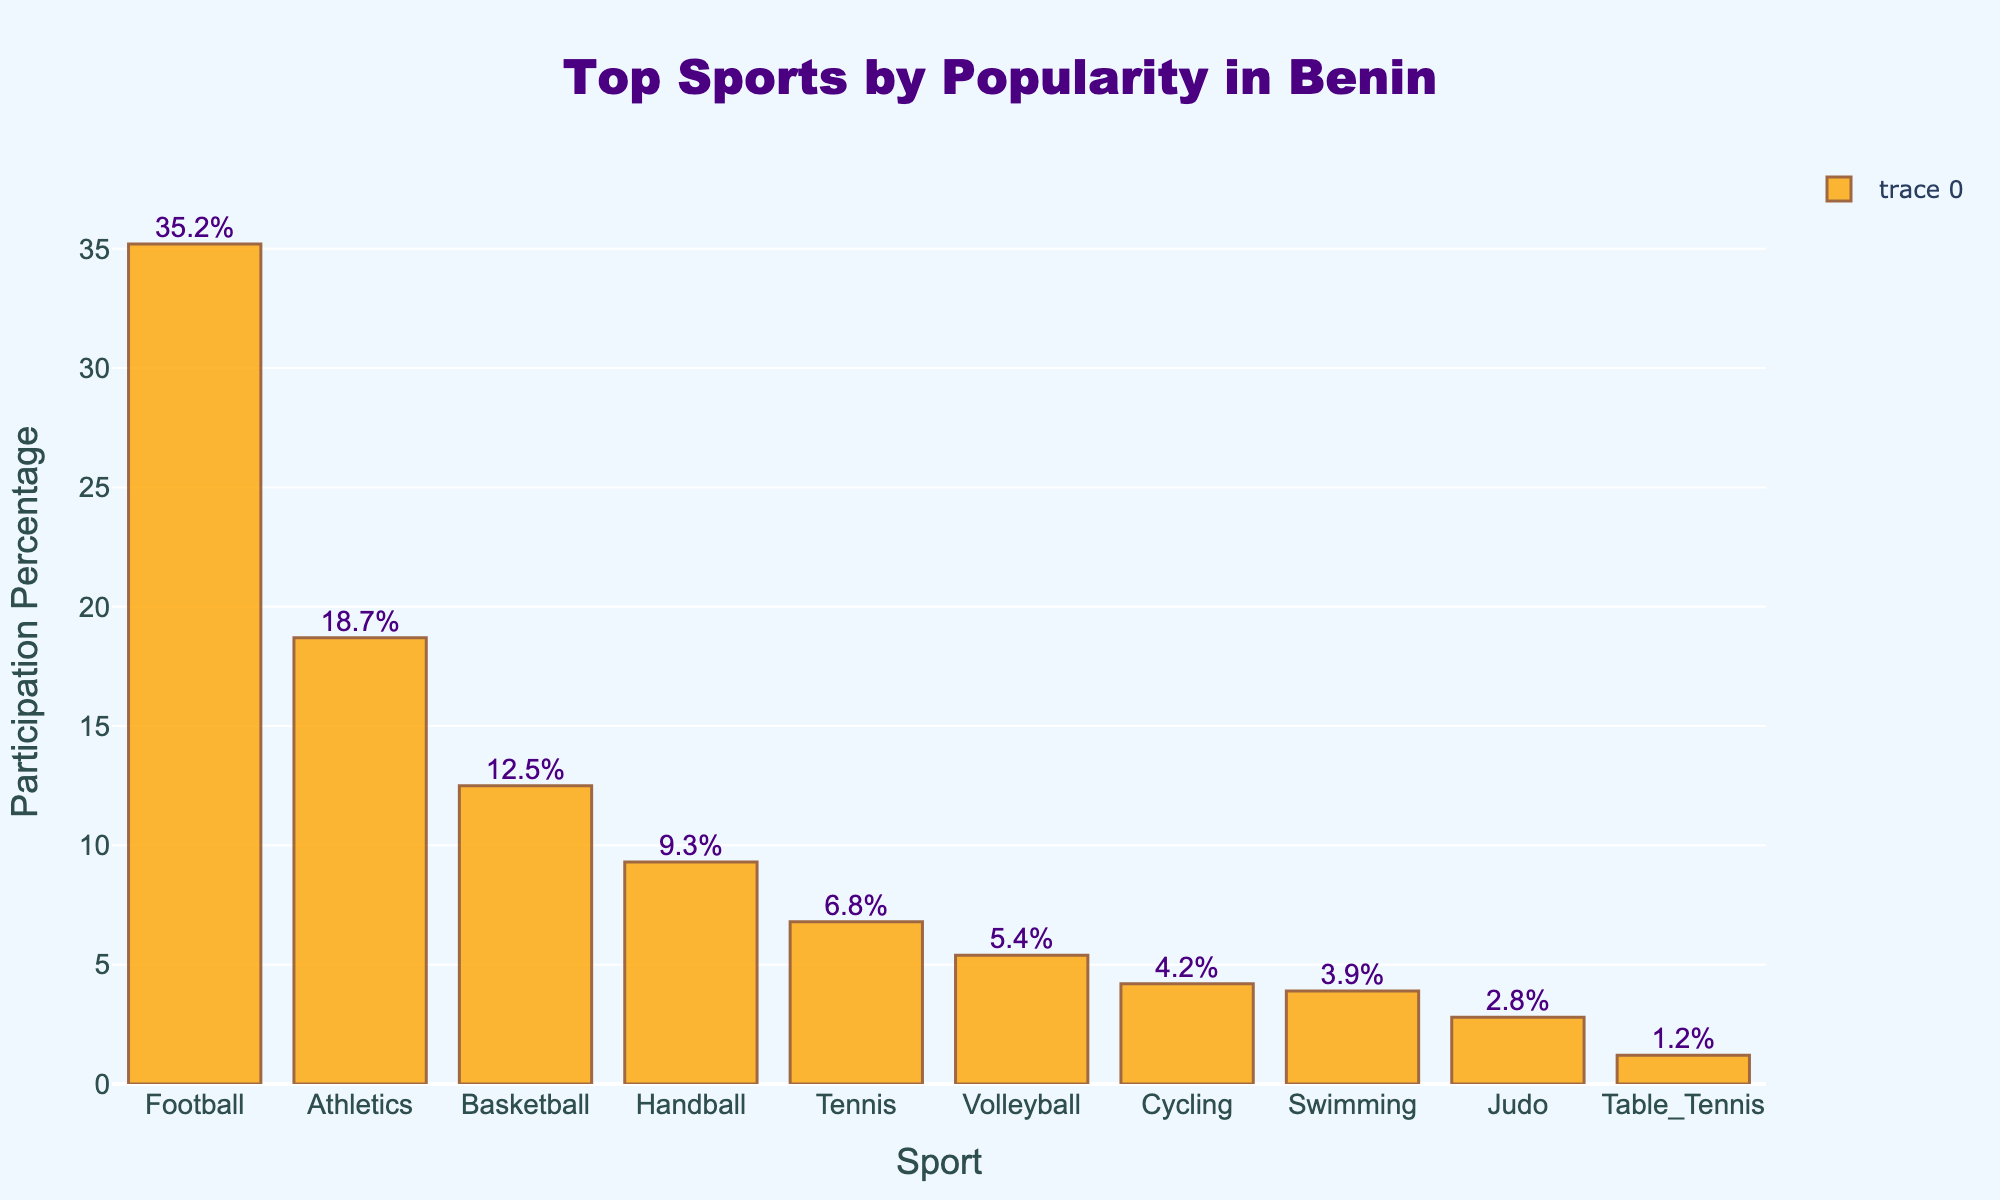What is the most popular sport in Benin? By looking at the highest bar on the chart, which represents Football with a participation percentage of 35.2%, we can identify it as the most popular sport in Benin.
Answer: Football Which sport has a higher participation percentage: Basketball or Handball? To compare Basketball and Handball, we look at the heights of their respective bars. Basketball has a participation percentage of 12.5%, while Handball has 9.3%. Since 12.5% is greater than 9.3%, Basketball has a higher participation percentage.
Answer: Basketball What is the combined participation percentage of the top three sports? The top three sports by popularity are Football, Athletics, and Basketball. Summing their participation percentages: 35.2% + 18.7% + 12.5% = 66.4%.
Answer: 66.4% How much more popular is Football compared to Tennis? To find the difference in popularity, subtract Tennis's participation percentage (6.8%) from Football's (35.2%): 35.2% - 6.8% = 28.4%.
Answer: 28.4% Which sport is ranked fourth in terms of popularity? By examining the bar chart and sorting the sports by their participation percentages in descending order, we see that Handball, with a participation percentage of 9.3%, is ranked fourth.
Answer: Handball What percentage of the population participates in sports other than the top three? First, calculate the combined participation percentage of the top three sports: Football (35.2%) + Athletics (18.7%) + Basketball (12.5%) = 66.4%. Next, subtract this from 100% to find the participation percentage for other sports: 100% - 66.4% = 33.6%.
Answer: 33.6% What is the average participation percentage of the top five sports? The top five sports are Football (35.2%), Athletics (18.7%), Basketball (12.5%), Handball (9.3%), and Tennis (6.8%). Calculate the average: (35.2 + 18.7 + 12.5 + 9.3 + 6.8) / 5 = 16.5%.
Answer: 16.5% By how much does the participation percentage of Volleyball differ from Cycling? Subtract Cycling's participation percentage (4.2%) from Volleyball's (5.4%): 5.4% - 4.2% = 1.2%.
Answer: 1.2% 